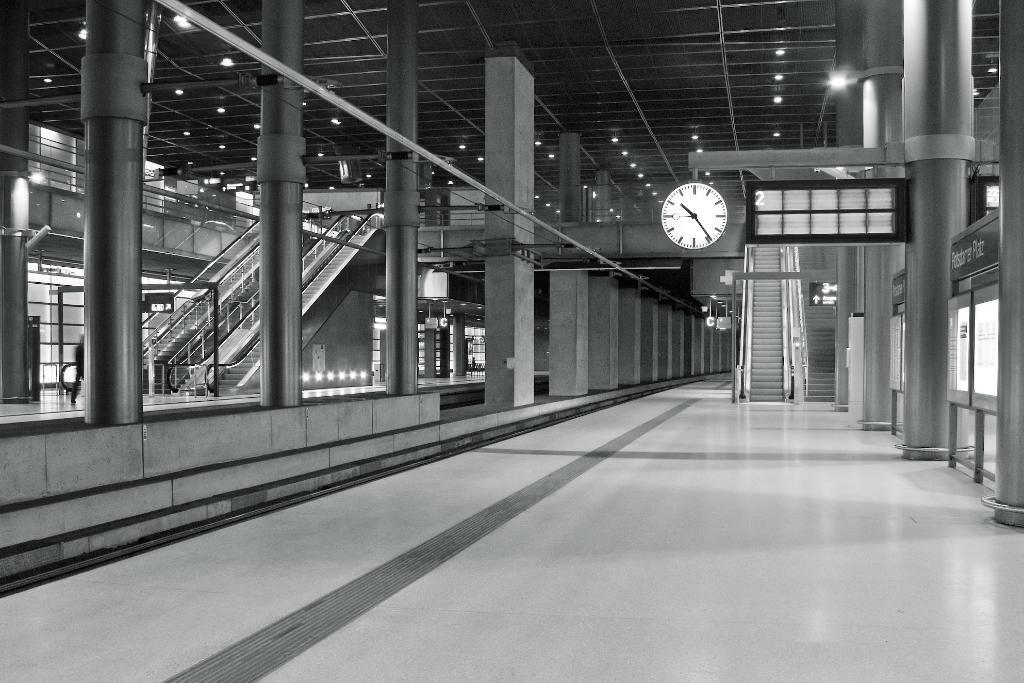In one or two sentences, can you explain what this image depicts? An inside picture of a building. Lights are attached to the ceiling. Here we can see pillars, clock, escalators, board and person.  